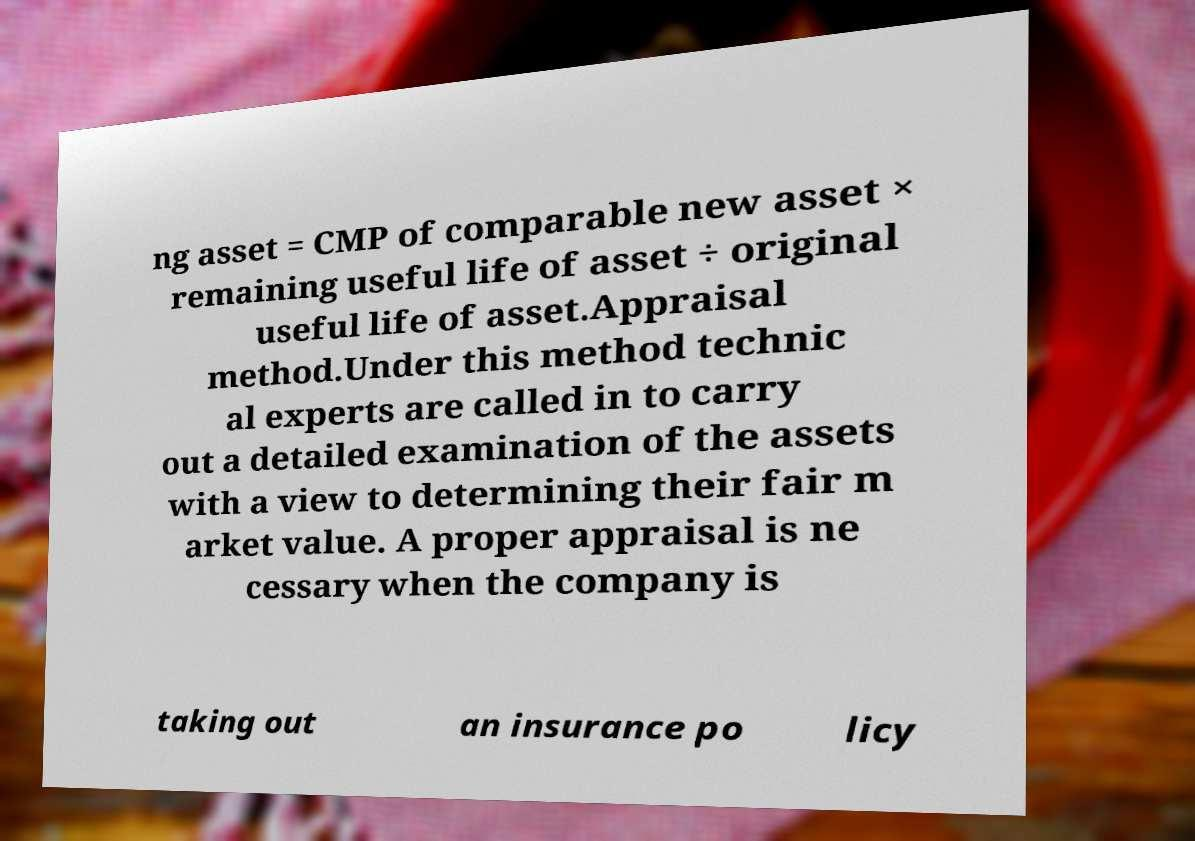Could you extract and type out the text from this image? ng asset = CMP of comparable new asset × remaining useful life of asset ÷ original useful life of asset.Appraisal method.Under this method technic al experts are called in to carry out a detailed examination of the assets with a view to determining their fair m arket value. A proper appraisal is ne cessary when the company is taking out an insurance po licy 